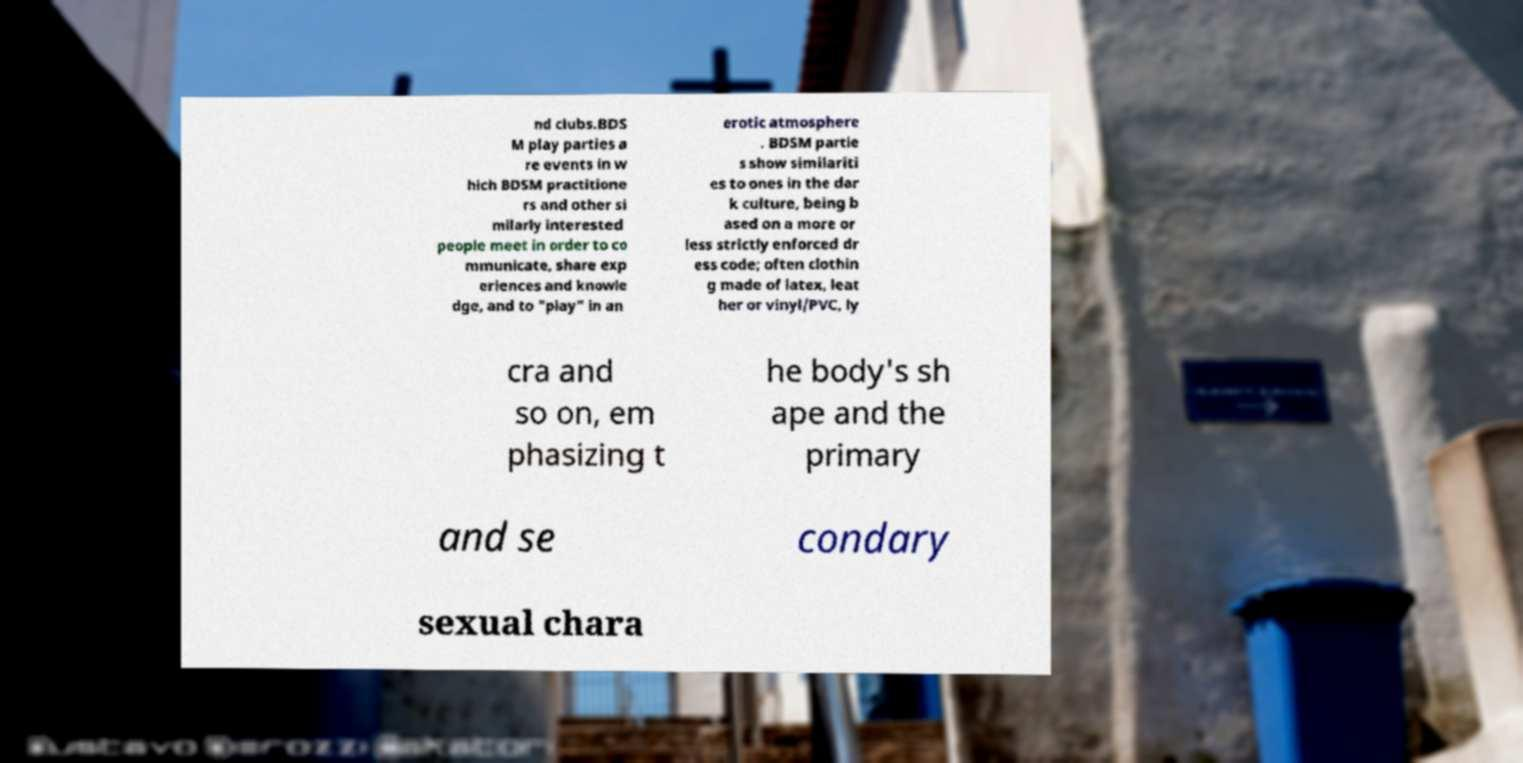There's text embedded in this image that I need extracted. Can you transcribe it verbatim? nd clubs.BDS M play parties a re events in w hich BDSM practitione rs and other si milarly interested people meet in order to co mmunicate, share exp eriences and knowle dge, and to "play" in an erotic atmosphere . BDSM partie s show similariti es to ones in the dar k culture, being b ased on a more or less strictly enforced dr ess code; often clothin g made of latex, leat her or vinyl/PVC, ly cra and so on, em phasizing t he body's sh ape and the primary and se condary sexual chara 